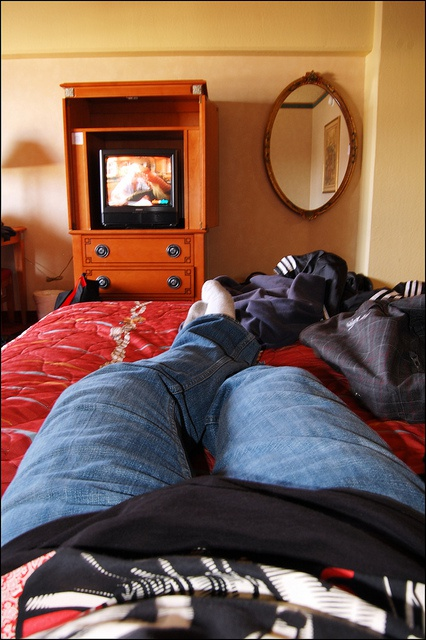Describe the objects in this image and their specific colors. I can see people in black and gray tones, bed in black, brown, salmon, and maroon tones, and tv in black, white, and tan tones in this image. 